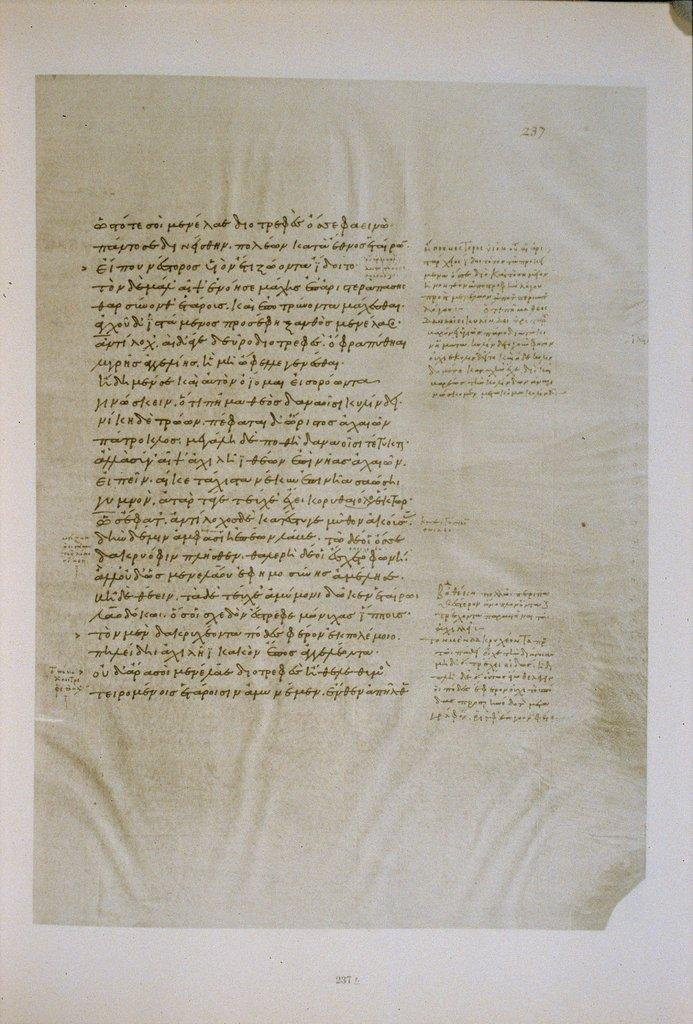<image>
Create a compact narrative representing the image presented. Page 237 from a book of calligraphy is on a white background. 